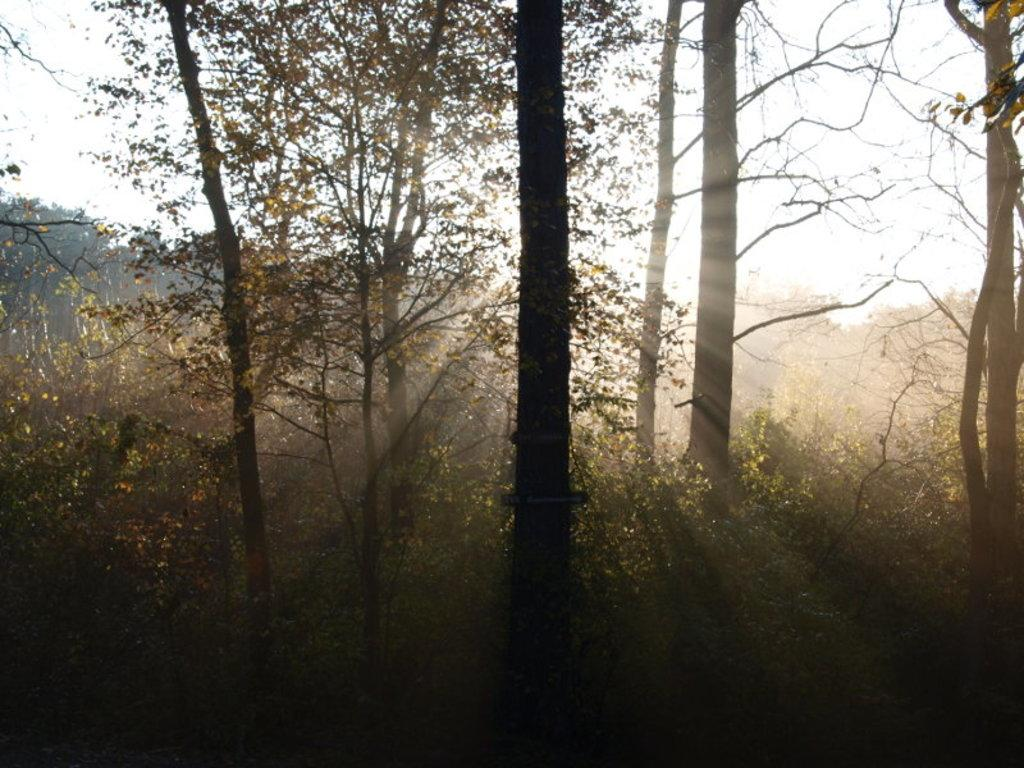What type of vegetation can be seen in the image? There are trees and plants in the image. What kind of environment is depicted in the image? The image appears to depict a forest. What is the source of light in the image? Sunlight is visible in the image. What type of pie is being served for lunch in the image? There is no pie or lunch depicted in the image; it features trees, plants, and sunlight in a forest setting. 